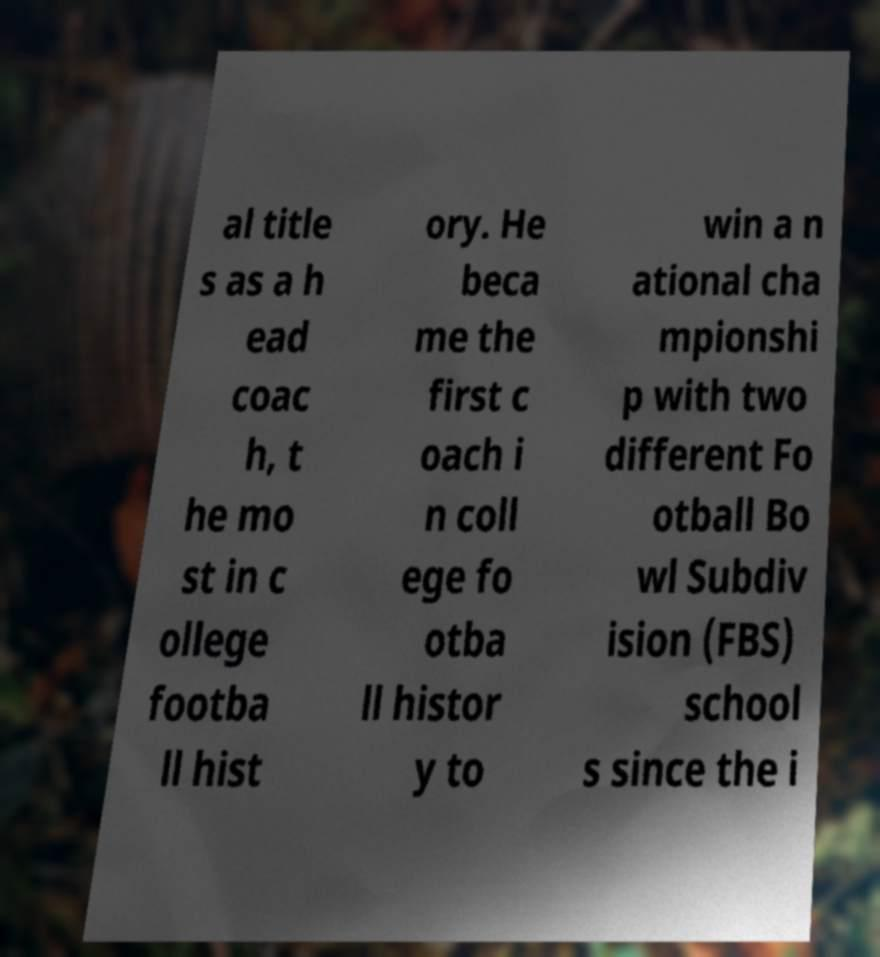There's text embedded in this image that I need extracted. Can you transcribe it verbatim? al title s as a h ead coac h, t he mo st in c ollege footba ll hist ory. He beca me the first c oach i n coll ege fo otba ll histor y to win a n ational cha mpionshi p with two different Fo otball Bo wl Subdiv ision (FBS) school s since the i 